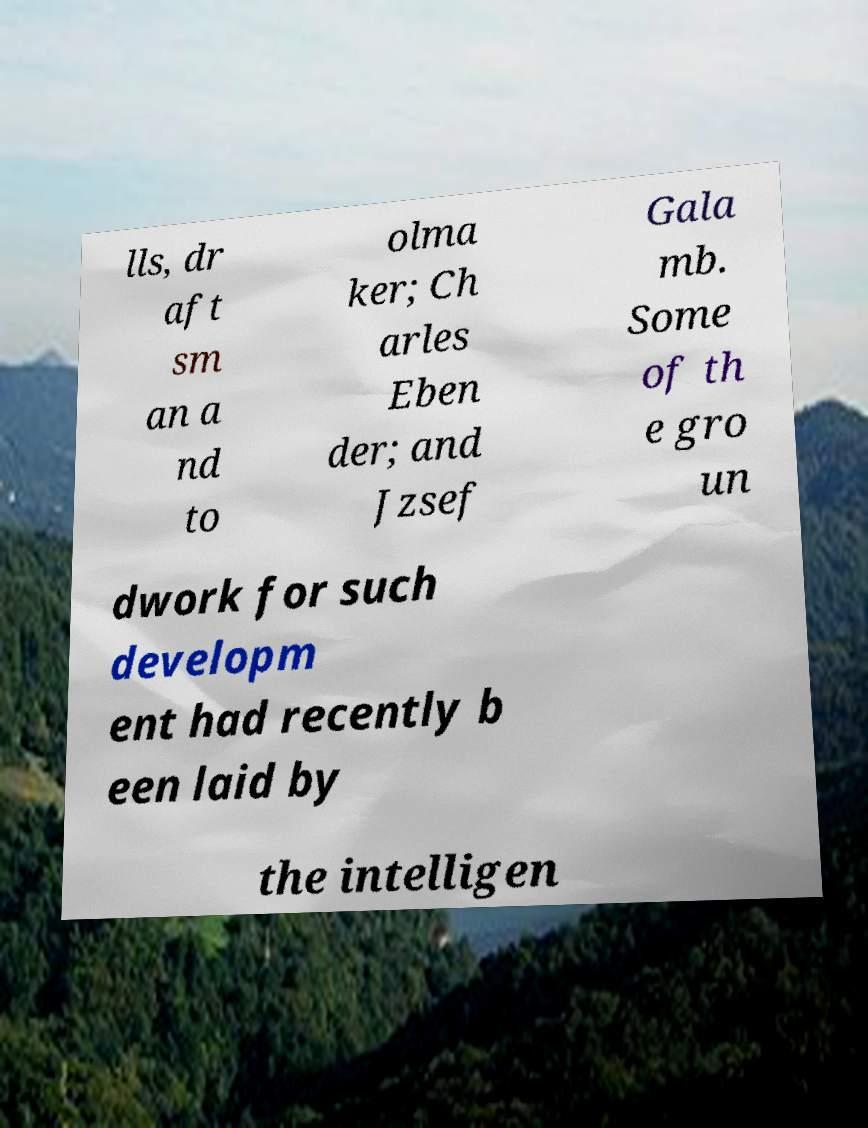Could you assist in decoding the text presented in this image and type it out clearly? lls, dr aft sm an a nd to olma ker; Ch arles Eben der; and Jzsef Gala mb. Some of th e gro un dwork for such developm ent had recently b een laid by the intelligen 